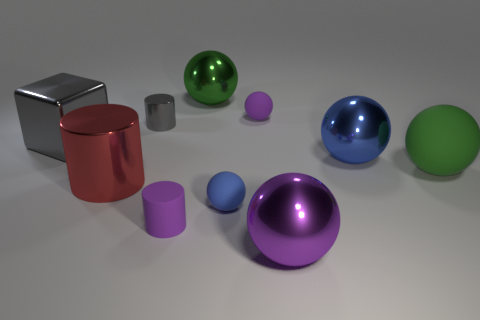Subtract all blue shiny balls. How many balls are left? 5 Subtract all blue spheres. How many spheres are left? 4 Subtract all cylinders. How many objects are left? 7 Subtract all gray cylinders. Subtract all gray balls. How many cylinders are left? 2 Subtract all blue cylinders. How many purple blocks are left? 0 Subtract all big objects. Subtract all small gray metal cylinders. How many objects are left? 3 Add 1 green matte spheres. How many green matte spheres are left? 2 Add 7 blue metal spheres. How many blue metal spheres exist? 8 Subtract 1 gray cubes. How many objects are left? 9 Subtract 4 spheres. How many spheres are left? 2 